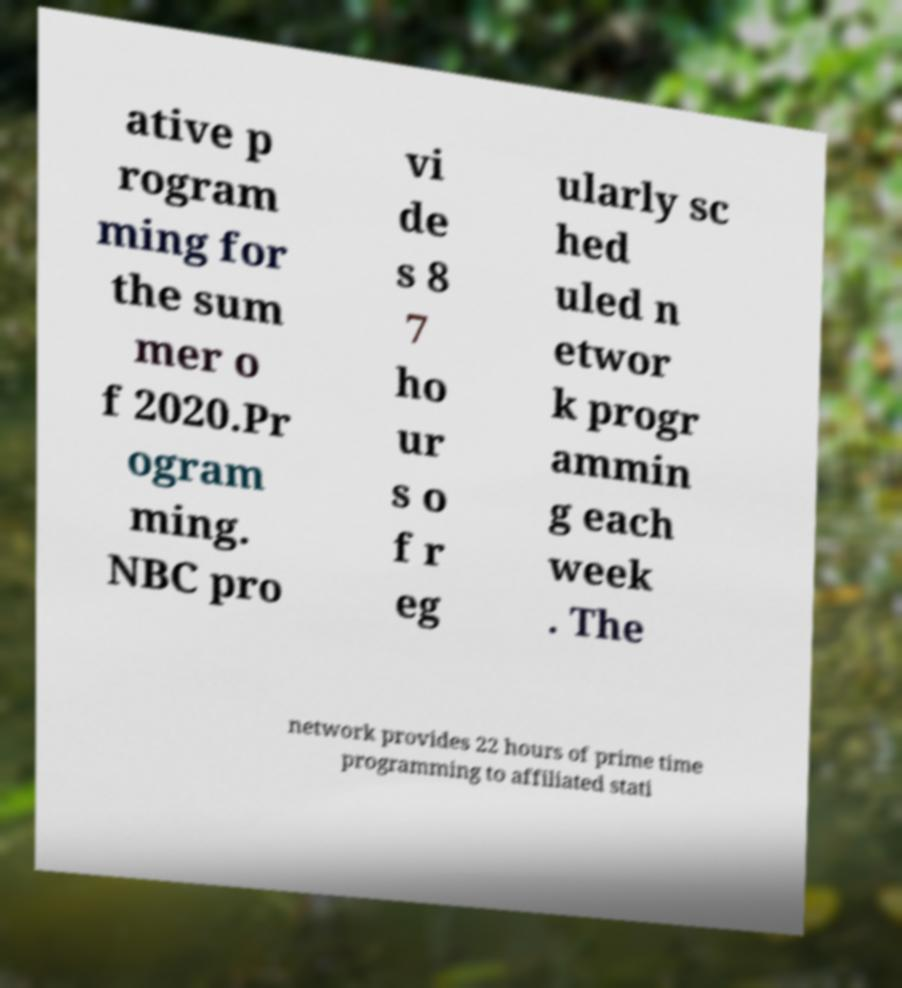There's text embedded in this image that I need extracted. Can you transcribe it verbatim? ative p rogram ming for the sum mer o f 2020.Pr ogram ming. NBC pro vi de s 8 7 ho ur s o f r eg ularly sc hed uled n etwor k progr ammin g each week . The network provides 22 hours of prime time programming to affiliated stati 